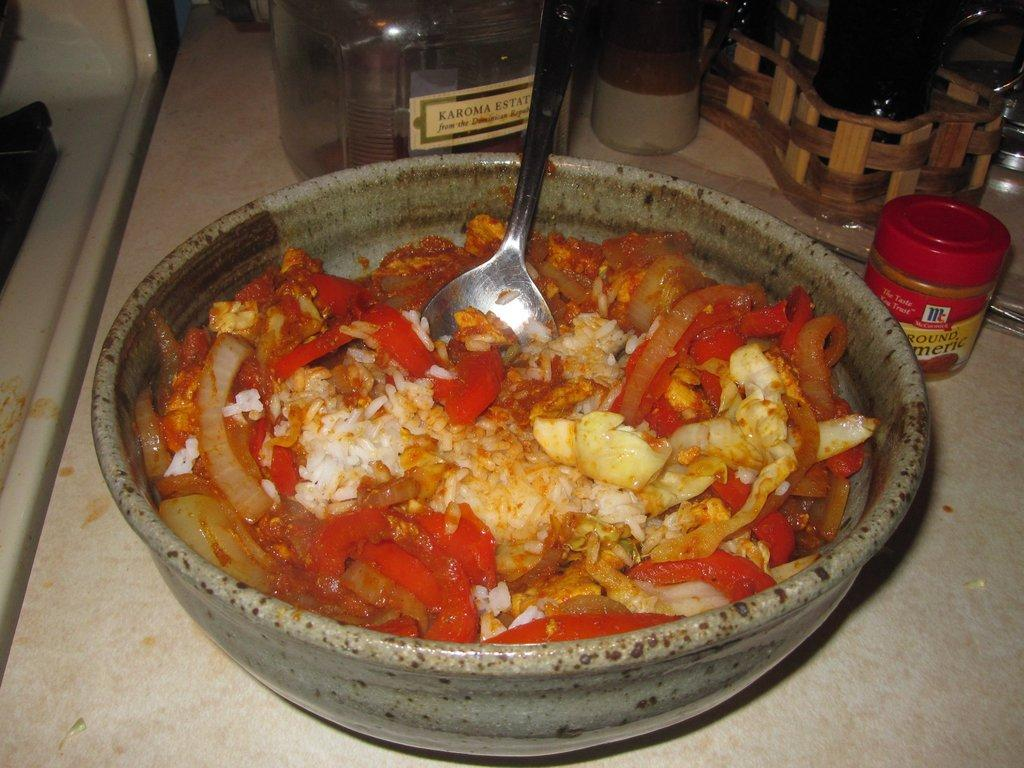What is located at the front of the image? There is a bowl in the front of the image. What is inside the bowl? There is food in the bowl. What utensil is in the bowl? There is a spoon in the bowl. What can be seen in the background of the image? There are bottles and a tray in the background of the image. What type of plant is growing on the drum in the image? There is no drum or plant present in the image. 